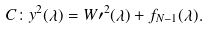<formula> <loc_0><loc_0><loc_500><loc_500>C \colon y ^ { 2 } ( \lambda ) = W \prime ^ { 2 } ( \lambda ) + f _ { N - 1 } ( \lambda ) .</formula> 